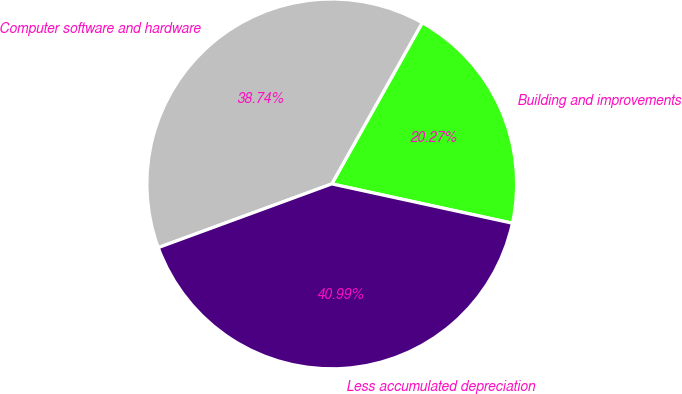Convert chart to OTSL. <chart><loc_0><loc_0><loc_500><loc_500><pie_chart><fcel>Building and improvements<fcel>Computer software and hardware<fcel>Less accumulated depreciation<nl><fcel>20.27%<fcel>38.74%<fcel>40.99%<nl></chart> 